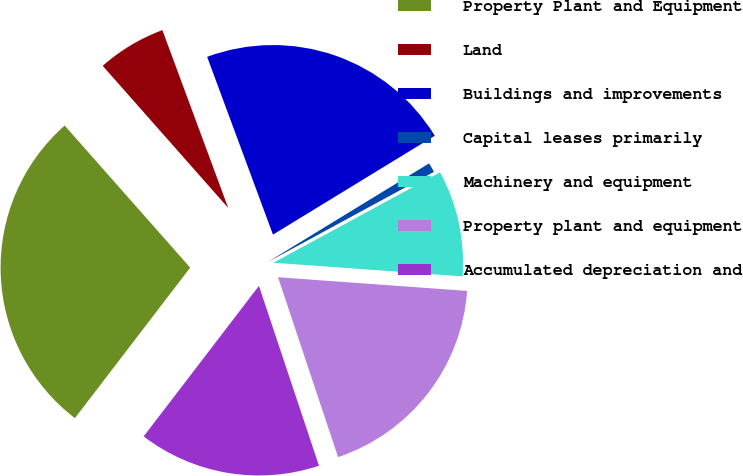Convert chart to OTSL. <chart><loc_0><loc_0><loc_500><loc_500><pie_chart><fcel>Property Plant and Equipment<fcel>Land<fcel>Buildings and improvements<fcel>Capital leases primarily<fcel>Machinery and equipment<fcel>Property plant and equipment<fcel>Accumulated depreciation and<nl><fcel>28.08%<fcel>5.87%<fcel>21.91%<fcel>0.82%<fcel>9.06%<fcel>18.72%<fcel>15.53%<nl></chart> 